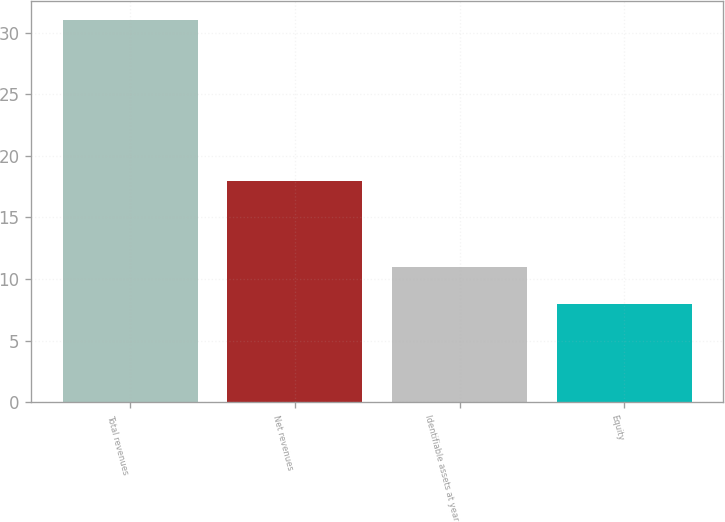Convert chart to OTSL. <chart><loc_0><loc_0><loc_500><loc_500><bar_chart><fcel>Total revenues<fcel>Net revenues<fcel>Identifiable assets at year<fcel>Equity<nl><fcel>31<fcel>18<fcel>11<fcel>8<nl></chart> 